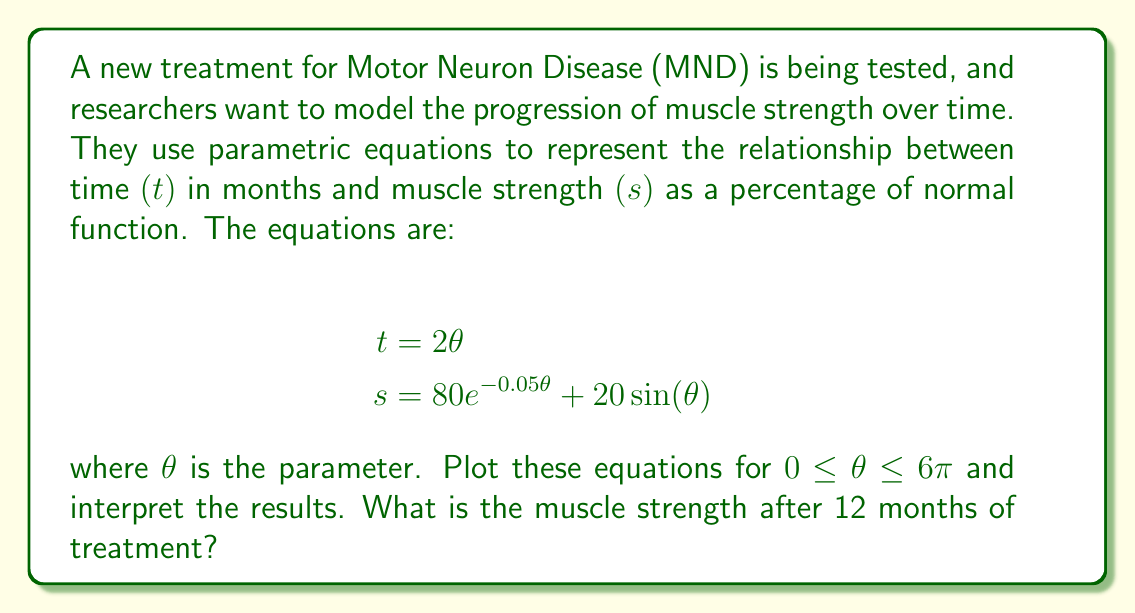Show me your answer to this math problem. To solve this problem and interpret the results, we'll follow these steps:

1) First, let's plot the parametric equations. We can use a graphing calculator or software to do this. The resulting curve will show how muscle strength changes over time.

[asy]
import graph;
size(200,200);

real x(real t) {return 2t;}
real y(real t) {return 80*exp(-0.05t) + 20*sin(t);}

draw(graph(x,y,0,6pi), red);

xaxis("Time (months)",arrow=Arrow);
yaxis("Muscle Strength (%)",arrow=Arrow);

label("$(0,100)$", (0,100), NW);
label("$(12,74.8)$", (12,74.8), SE);
[/asy]

2) Interpreting the plot:
   - The curve starts at $(0,100)$, indicating 100% muscle strength at the beginning of treatment.
   - There's an overall declining trend, suggesting that muscle strength generally decreases over time despite treatment.
   - The curve shows periodic fluctuations, which could represent temporary improvements or setbacks in muscle strength.

3) To find the muscle strength after 12 months:
   - We need to find $\theta$ when $t = 12$
   - From the first equation: $12 = 2\theta$
   - Solving for $\theta$: $\theta = 6$

4) Now we can calculate $s$ when $\theta = 6$:
   $$\begin{align}
   s &= 80e^{-0.05(6)} + 20\sin(6) \\
   &= 80e^{-0.3} + 20\sin(6) \\
   &\approx 80(0.7408) + 20(-0.2794) \\
   &\approx 59.26 - 5.59 \\
   &\approx 53.67
   \end{align}$$

Therefore, after 12 months of treatment, the muscle strength is approximately 53.67% of normal function.
Answer: After 12 months of treatment, the muscle strength is approximately 53.67% of normal function. 